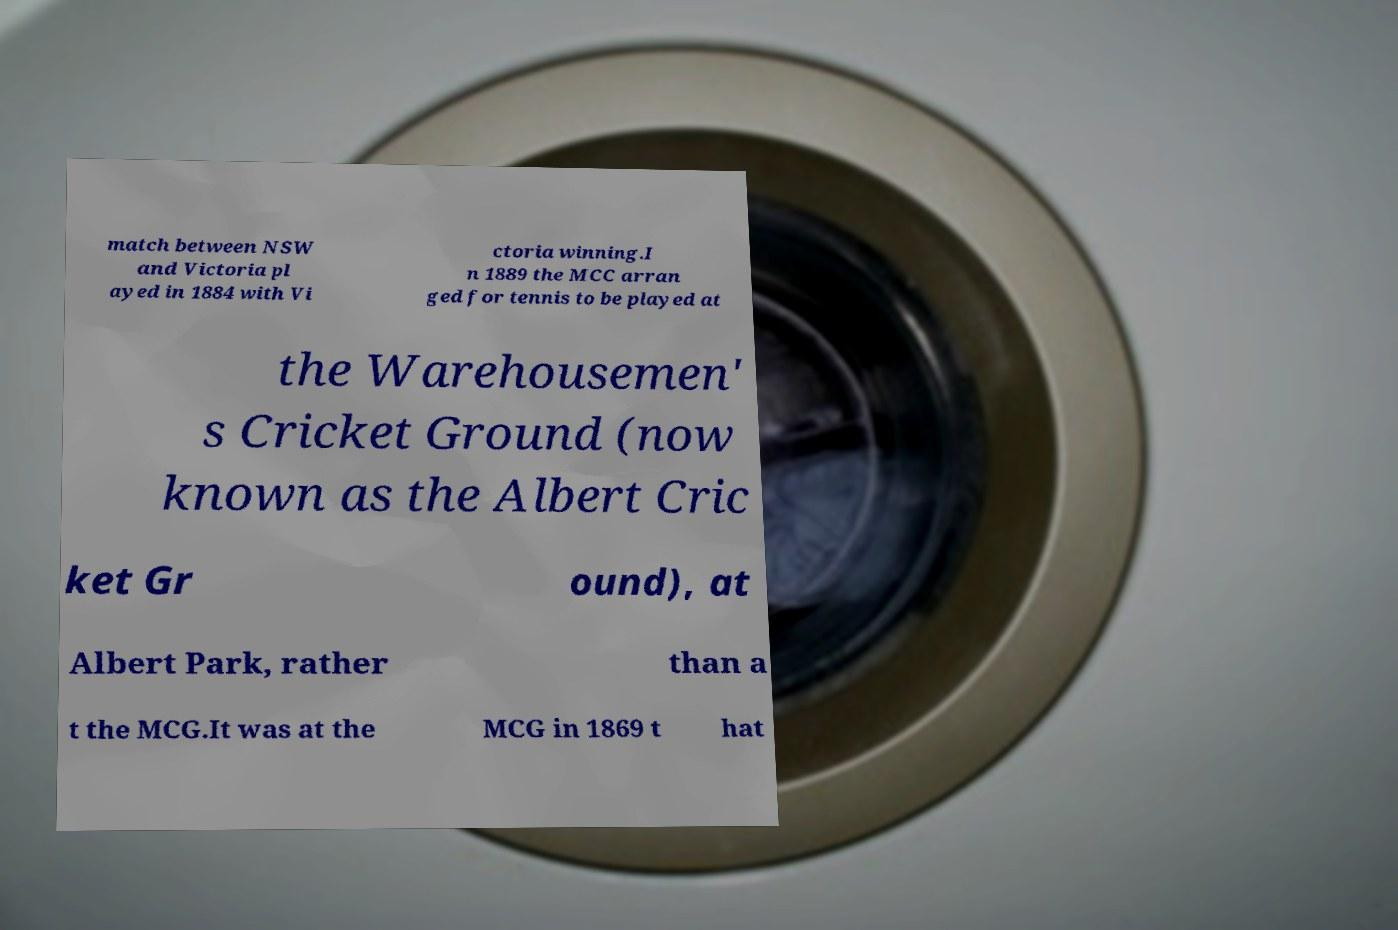Can you read and provide the text displayed in the image?This photo seems to have some interesting text. Can you extract and type it out for me? match between NSW and Victoria pl ayed in 1884 with Vi ctoria winning.I n 1889 the MCC arran ged for tennis to be played at the Warehousemen' s Cricket Ground (now known as the Albert Cric ket Gr ound), at Albert Park, rather than a t the MCG.It was at the MCG in 1869 t hat 